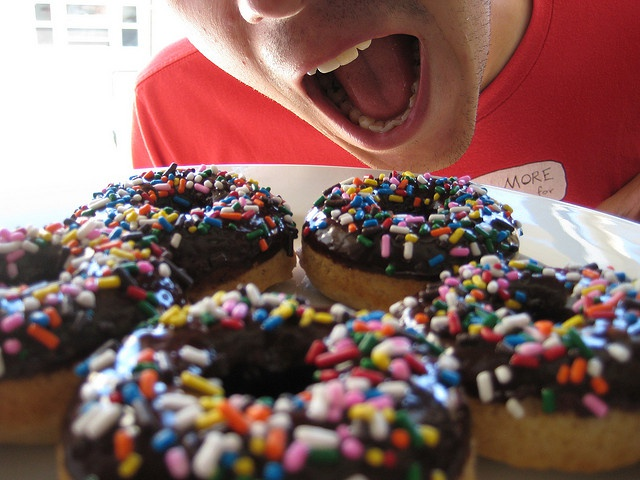Describe the objects in this image and their specific colors. I can see people in white, maroon, brown, and red tones, donut in white, black, gray, maroon, and darkgray tones, donut in white, black, maroon, and gray tones, donut in white, black, maroon, gray, and darkgray tones, and donut in white, black, maroon, and gray tones in this image. 